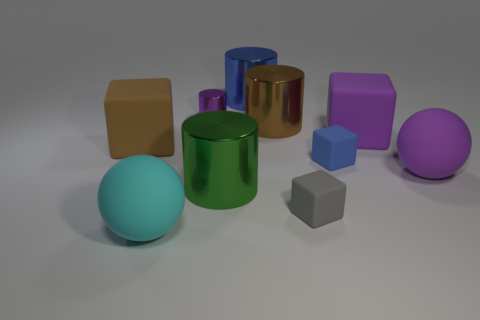Subtract 1 cubes. How many cubes are left? 3 Subtract all cubes. How many objects are left? 6 Add 1 brown objects. How many brown objects are left? 3 Add 4 matte spheres. How many matte spheres exist? 6 Subtract 1 purple blocks. How many objects are left? 9 Subtract all large cyan spheres. Subtract all blue rubber objects. How many objects are left? 8 